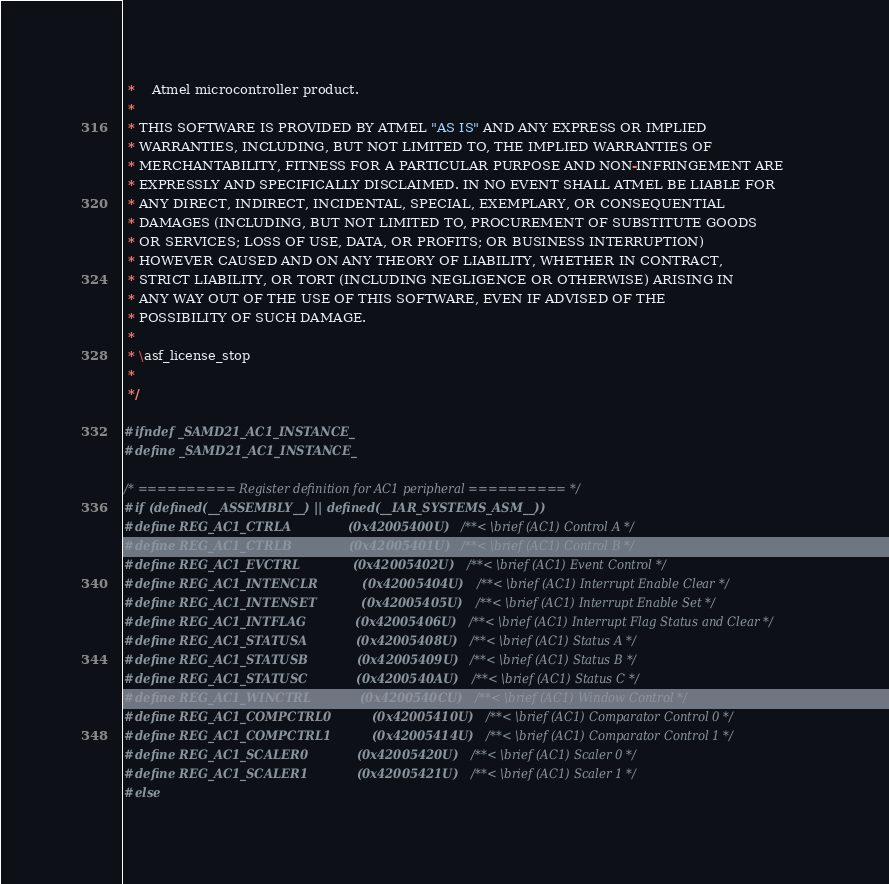<code> <loc_0><loc_0><loc_500><loc_500><_C_> *    Atmel microcontroller product.
 *
 * THIS SOFTWARE IS PROVIDED BY ATMEL "AS IS" AND ANY EXPRESS OR IMPLIED
 * WARRANTIES, INCLUDING, BUT NOT LIMITED TO, THE IMPLIED WARRANTIES OF
 * MERCHANTABILITY, FITNESS FOR A PARTICULAR PURPOSE AND NON-INFRINGEMENT ARE
 * EXPRESSLY AND SPECIFICALLY DISCLAIMED. IN NO EVENT SHALL ATMEL BE LIABLE FOR
 * ANY DIRECT, INDIRECT, INCIDENTAL, SPECIAL, EXEMPLARY, OR CONSEQUENTIAL
 * DAMAGES (INCLUDING, BUT NOT LIMITED TO, PROCUREMENT OF SUBSTITUTE GOODS
 * OR SERVICES; LOSS OF USE, DATA, OR PROFITS; OR BUSINESS INTERRUPTION)
 * HOWEVER CAUSED AND ON ANY THEORY OF LIABILITY, WHETHER IN CONTRACT,
 * STRICT LIABILITY, OR TORT (INCLUDING NEGLIGENCE OR OTHERWISE) ARISING IN
 * ANY WAY OUT OF THE USE OF THIS SOFTWARE, EVEN IF ADVISED OF THE
 * POSSIBILITY OF SUCH DAMAGE.
 *
 * \asf_license_stop
 *
 */

#ifndef _SAMD21_AC1_INSTANCE_
#define _SAMD21_AC1_INSTANCE_

/* ========== Register definition for AC1 peripheral ========== */
#if (defined(__ASSEMBLY__) || defined(__IAR_SYSTEMS_ASM__))
#define REG_AC1_CTRLA              (0x42005400U) /**< \brief (AC1) Control A */
#define REG_AC1_CTRLB              (0x42005401U) /**< \brief (AC1) Control B */
#define REG_AC1_EVCTRL             (0x42005402U) /**< \brief (AC1) Event Control */
#define REG_AC1_INTENCLR           (0x42005404U) /**< \brief (AC1) Interrupt Enable Clear */
#define REG_AC1_INTENSET           (0x42005405U) /**< \brief (AC1) Interrupt Enable Set */
#define REG_AC1_INTFLAG            (0x42005406U) /**< \brief (AC1) Interrupt Flag Status and Clear */
#define REG_AC1_STATUSA            (0x42005408U) /**< \brief (AC1) Status A */
#define REG_AC1_STATUSB            (0x42005409U) /**< \brief (AC1) Status B */
#define REG_AC1_STATUSC            (0x4200540AU) /**< \brief (AC1) Status C */
#define REG_AC1_WINCTRL            (0x4200540CU) /**< \brief (AC1) Window Control */
#define REG_AC1_COMPCTRL0          (0x42005410U) /**< \brief (AC1) Comparator Control 0 */
#define REG_AC1_COMPCTRL1          (0x42005414U) /**< \brief (AC1) Comparator Control 1 */
#define REG_AC1_SCALER0            (0x42005420U) /**< \brief (AC1) Scaler 0 */
#define REG_AC1_SCALER1            (0x42005421U) /**< \brief (AC1) Scaler 1 */
#else</code> 